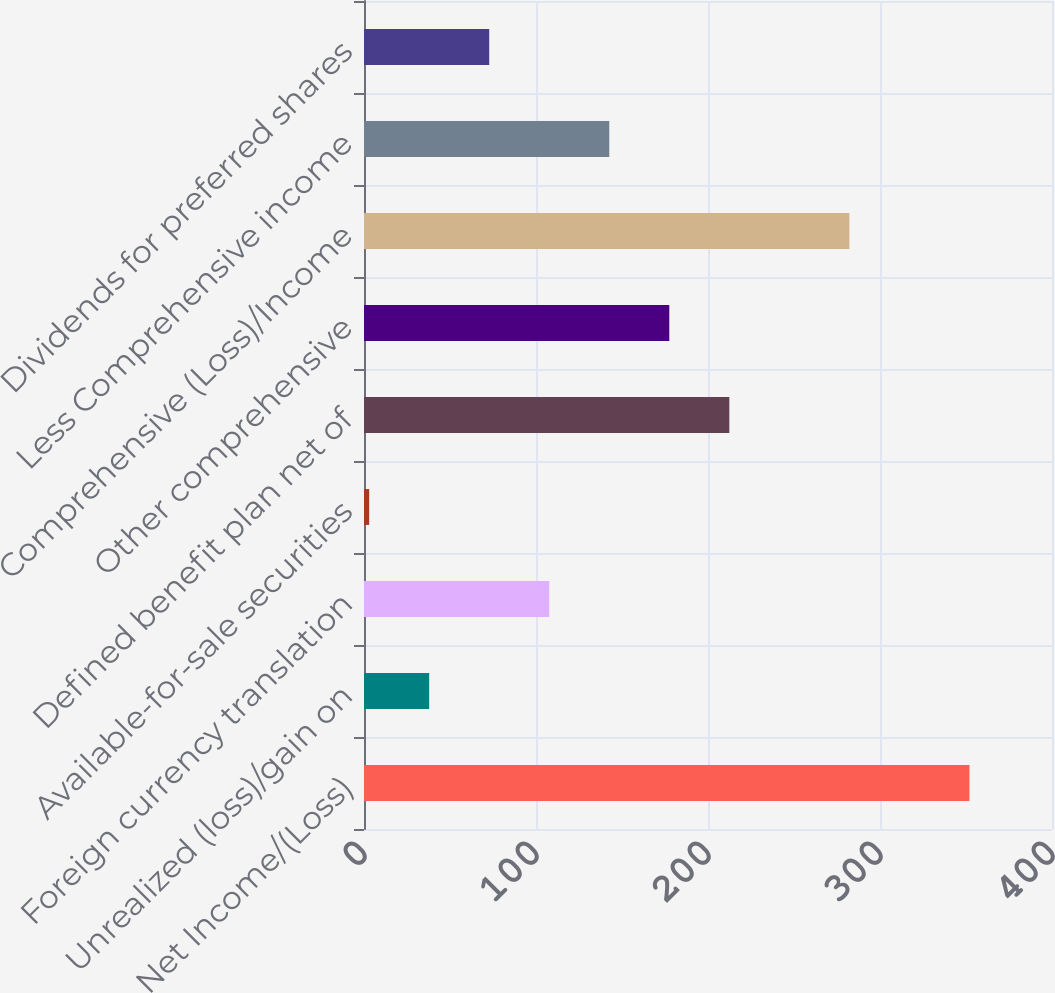<chart> <loc_0><loc_0><loc_500><loc_500><bar_chart><fcel>Net Income/(Loss)<fcel>Unrealized (loss)/gain on<fcel>Foreign currency translation<fcel>Available-for-sale securities<fcel>Defined benefit plan net of<fcel>Other comprehensive<fcel>Comprehensive (Loss)/Income<fcel>Less Comprehensive income<fcel>Dividends for preferred shares<nl><fcel>352<fcel>37.9<fcel>107.7<fcel>3<fcel>212.4<fcel>177.5<fcel>282.2<fcel>142.6<fcel>72.8<nl></chart> 